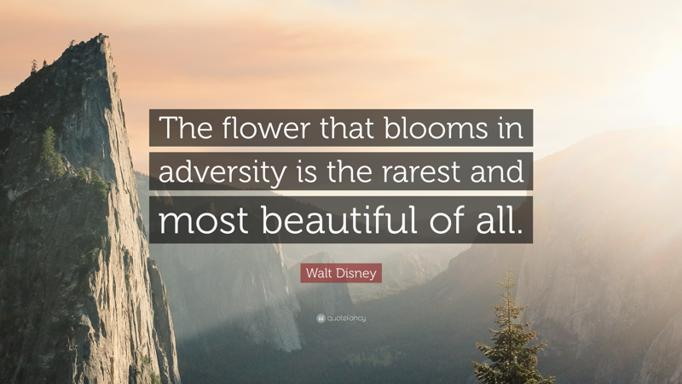What does the Walt Disney quote mean? The quote by Walt Disney, 'The flower that blooms in adversity is the rarest and most beautiful of all,' highlights a profound truth: those who withstand and flourish despite challenging conditions possess a unique beauty and strength. This concept mirrors nature where often, the most stunning blooms arise in the harshest environments, symbolizing resilience and the potential to overcome difficulties with grace and vigor. 